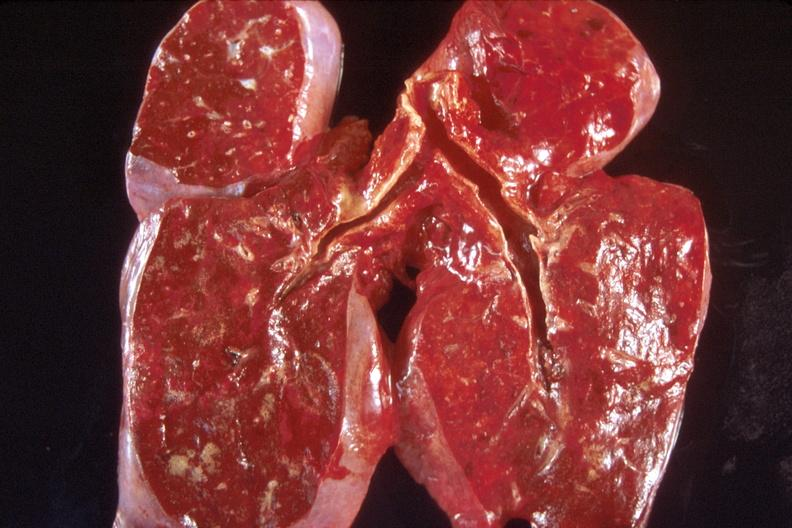what does this image show?
Answer the question using a single word or phrase. Lung 